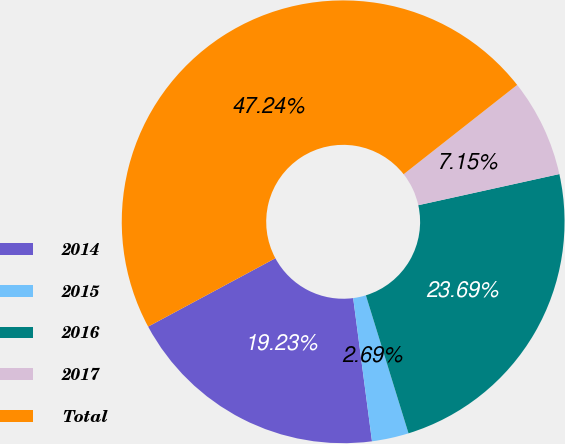Convert chart. <chart><loc_0><loc_0><loc_500><loc_500><pie_chart><fcel>2014<fcel>2015<fcel>2016<fcel>2017<fcel>Total<nl><fcel>19.23%<fcel>2.69%<fcel>23.69%<fcel>7.15%<fcel>47.24%<nl></chart> 